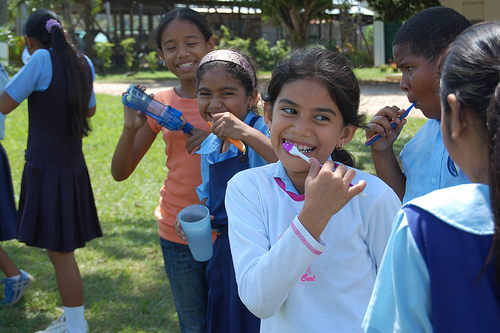Why do you think dental hygiene is being emphasized in a group setting here? Promoting dental hygiene in a group setting among children not only makes the process more enjoyable but also instills important health habits through a communal and supportive approach. What benefits does communal learning have for children? Communal learning fosters a sense of cooperation and mutual support. It helps children learn from each other, enhances social bonds, and can make learning more dynamic and memorable. 